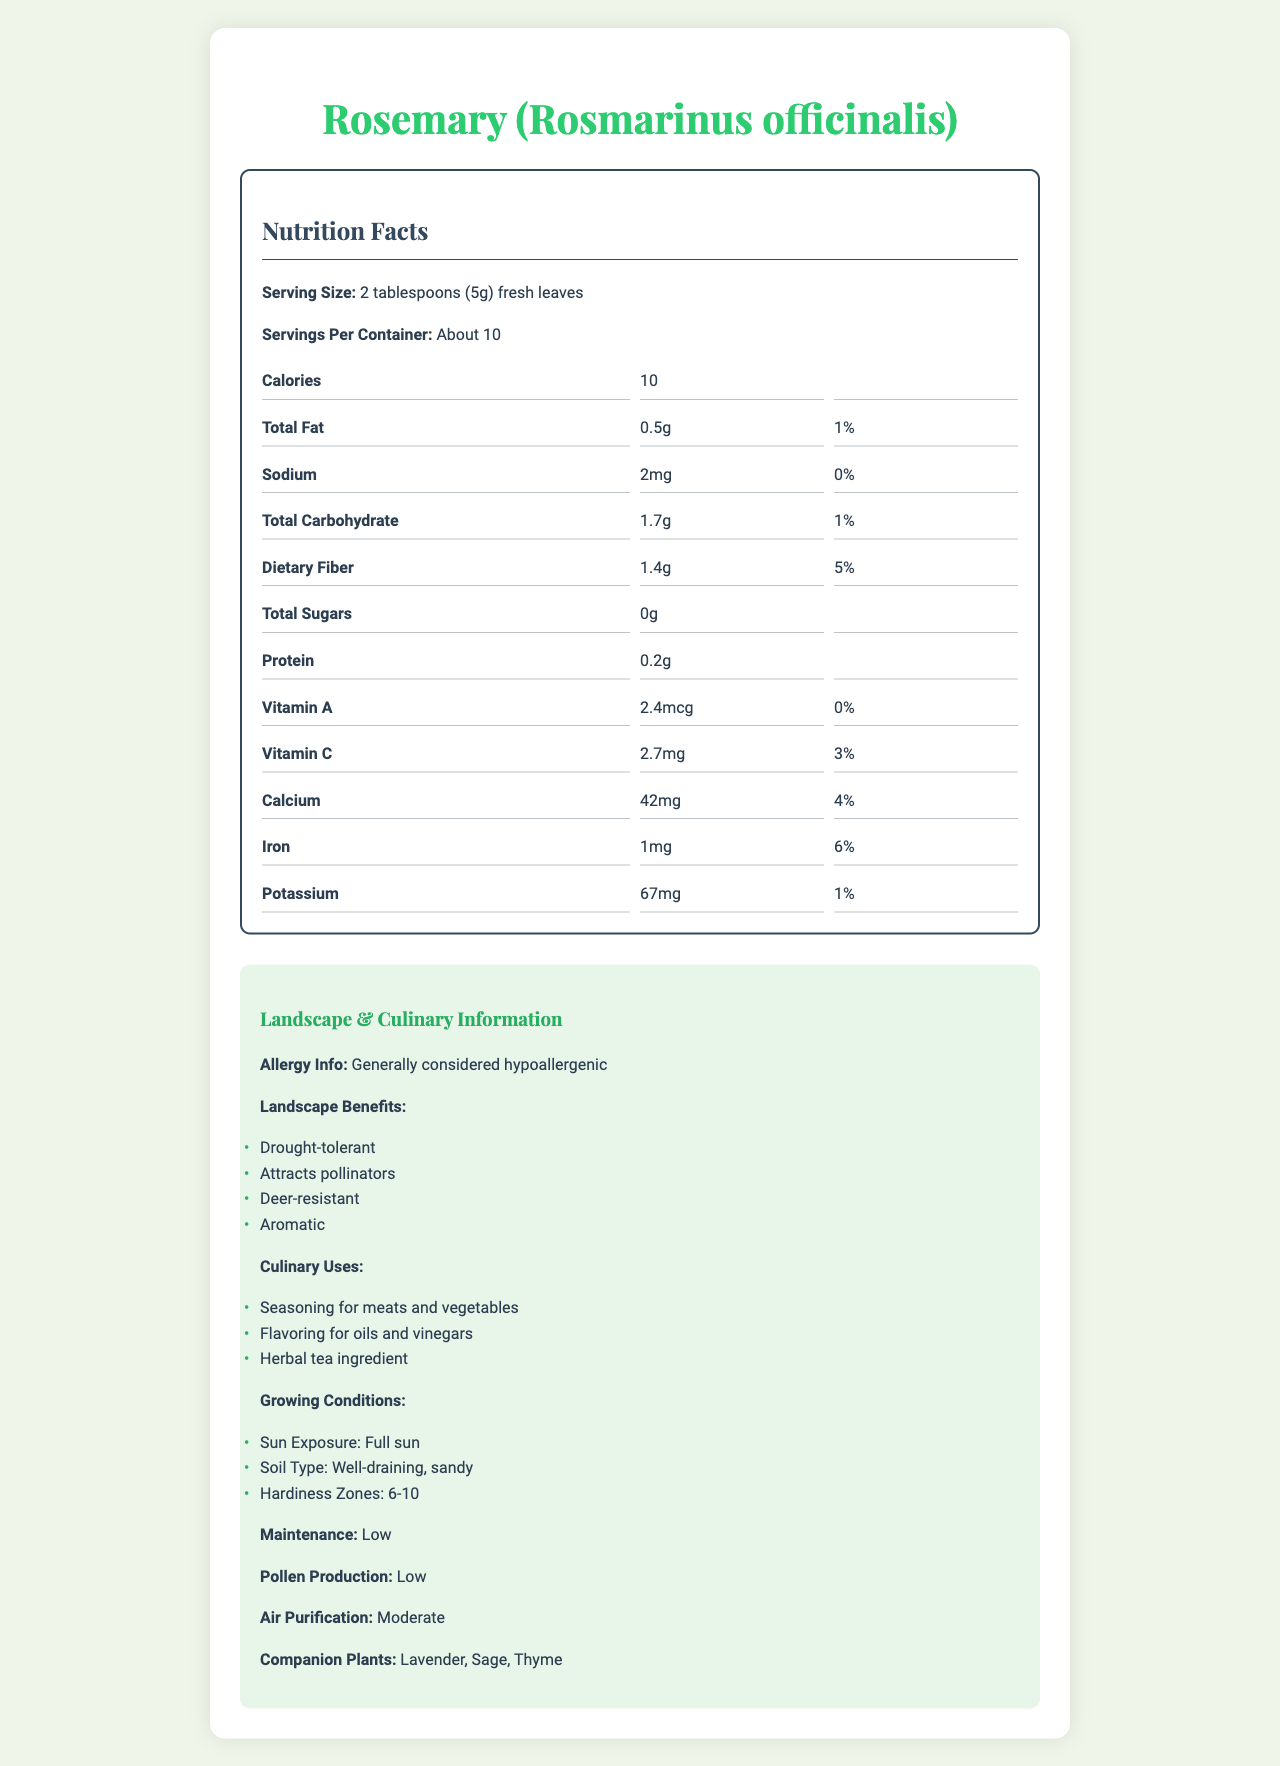what is the serving size for Rosemary? The document specifies the serving size at the top in the "Nutrition Facts" section.
Answer: 2 tablespoons (5g) fresh leaves how many calories are in one serving of Rosemary? The "Calories" section indicates that there are 10 calories per serving.
Answer: 10 how much dietary fiber does Rosemary provide? The "Dietary Fiber" section in the nutrition facts indicates that it contains 1.4g of dietary fiber per serving.
Answer: 1.4g list some culinary uses for Rosemary. The "Culinary Uses" section lists the different ways rosemary can be used in cooking.
Answer: Seasoning for meats and vegetables, Flavoring for oils and vinegars, Herbal tea ingredient what are the companion plants for Rosemary? The "Landscape & Culinary Information" section lists the companion plants.
Answer: Lavender, Sage, Thyme how much protein does Rosemary contain per serving? The "Protein" section in the nutrition facts indicates it has 0.2g of protein per serving.
Answer: 0.2g What type of soil is recommended for growing Rosemary? The "Growing Conditions" section specifies that rosemary needs well-draining, sandy soil.
Answer: Well-draining, sandy how much calcium is in one serving of Rosemary? A. 5mg B. 42g C. 10mg D. 42mg The calcium content is listed as 42mg per serving in the nutrition facts.
Answer: D. 42mg which of the following is NOT a benefit of Rosemary? I. Deer-resistant II. Attracts pollinators III. High pollen production The "Landscape Benefits" section mentions all except high pollen production, and it is stated that rosemary has low pollen production.
Answer: III. High pollen production is Rosemary considered hypoallergenic? The "Allergy Info" section states that rosemary is generally considered hypoallergenic.
Answer: Yes summarize the main nutritional benefits of Rosemary. The nutritional label highlights that rosemary is low in calories and fat, with a strong dietary fiber content. Additionally, it contains important minerals like calcium and iron, while being generally hypoallergenic. It also offers many landscape and culinary uses.
Answer: Rosemary provides a low-calorie, low-fat option with significant dietary fiber and notable amounts of calcium and iron. It is also hypoallergenic and offers multiple landscape and culinary benefits. what is the daily value percentage of iron in one serving of Rosemary? The "Iron" section in the nutrition facts indicates that it provides 6% of the daily value per serving.
Answer: 6% can the document provide the exact growing duration for Rosemary? The document mentions growing conditions but does not specify the exact duration for rosemary growth.
Answer: Not enough information 